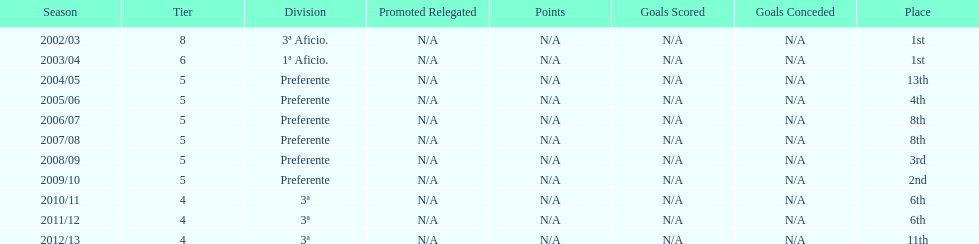What place was 1a aficio and 3a aficio? 1st. 